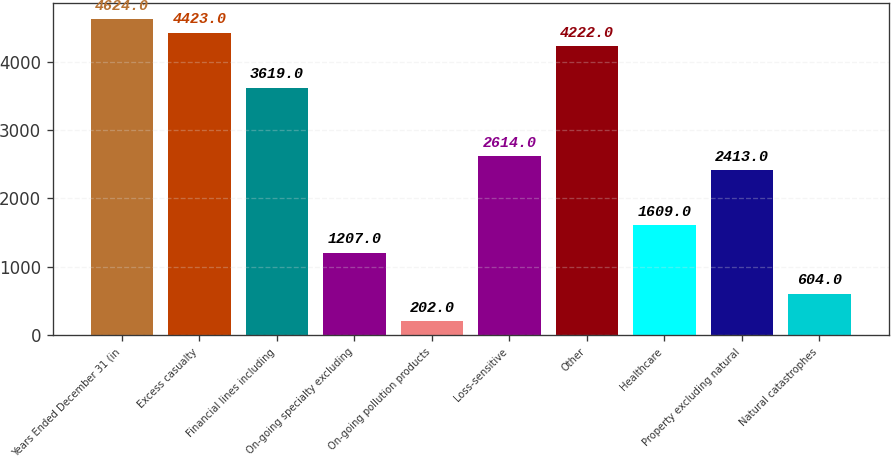Convert chart to OTSL. <chart><loc_0><loc_0><loc_500><loc_500><bar_chart><fcel>Years Ended December 31 (in<fcel>Excess casualty<fcel>Financial lines including<fcel>On-going specialty excluding<fcel>On-going pollution products<fcel>Loss-sensitive<fcel>Other<fcel>Healthcare<fcel>Property excluding natural<fcel>Natural catastrophes<nl><fcel>4624<fcel>4423<fcel>3619<fcel>1207<fcel>202<fcel>2614<fcel>4222<fcel>1609<fcel>2413<fcel>604<nl></chart> 